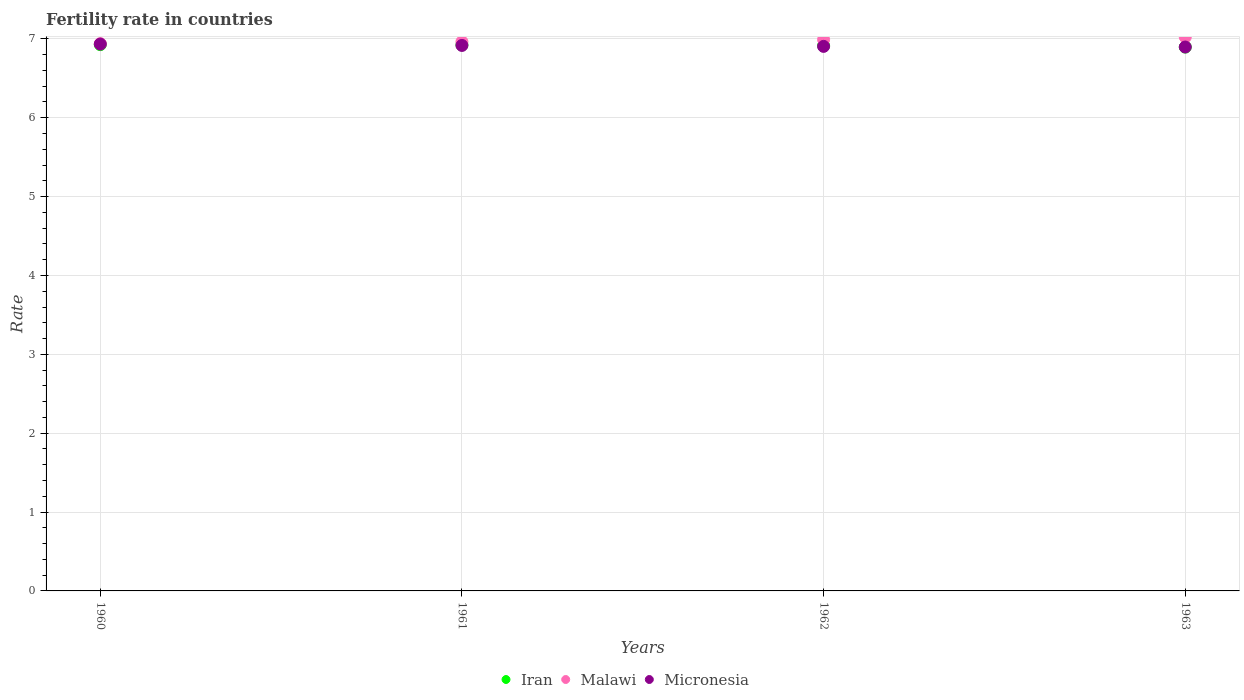How many different coloured dotlines are there?
Your response must be concise. 3. What is the fertility rate in Malawi in 1961?
Provide a short and direct response. 6.96. Across all years, what is the maximum fertility rate in Iran?
Provide a short and direct response. 6.93. Across all years, what is the minimum fertility rate in Iran?
Give a very brief answer. 6.9. What is the total fertility rate in Iran in the graph?
Provide a succinct answer. 27.66. What is the difference between the fertility rate in Iran in 1960 and that in 1962?
Offer a very short reply. 0.01. What is the difference between the fertility rate in Malawi in 1960 and the fertility rate in Iran in 1961?
Offer a terse response. 0.02. What is the average fertility rate in Malawi per year?
Your answer should be compact. 6.98. In the year 1961, what is the difference between the fertility rate in Micronesia and fertility rate in Malawi?
Your answer should be compact. -0.05. In how many years, is the fertility rate in Iran greater than 5.4?
Your answer should be very brief. 4. What is the ratio of the fertility rate in Iran in 1961 to that in 1963?
Your response must be concise. 1. Is the fertility rate in Malawi in 1960 less than that in 1962?
Provide a succinct answer. Yes. What is the difference between the highest and the second highest fertility rate in Malawi?
Offer a terse response. 0.03. What is the difference between the highest and the lowest fertility rate in Iran?
Offer a very short reply. 0.03. Is it the case that in every year, the sum of the fertility rate in Malawi and fertility rate in Iran  is greater than the fertility rate in Micronesia?
Provide a succinct answer. Yes. Does the fertility rate in Micronesia monotonically increase over the years?
Offer a very short reply. No. Is the fertility rate in Micronesia strictly greater than the fertility rate in Malawi over the years?
Keep it short and to the point. No. Is the fertility rate in Micronesia strictly less than the fertility rate in Malawi over the years?
Provide a short and direct response. Yes. How many dotlines are there?
Give a very brief answer. 3. What is the difference between two consecutive major ticks on the Y-axis?
Your response must be concise. 1. Are the values on the major ticks of Y-axis written in scientific E-notation?
Keep it short and to the point. No. Does the graph contain any zero values?
Your answer should be very brief. No. What is the title of the graph?
Give a very brief answer. Fertility rate in countries. Does "Faeroe Islands" appear as one of the legend labels in the graph?
Offer a very short reply. No. What is the label or title of the Y-axis?
Your answer should be compact. Rate. What is the Rate in Iran in 1960?
Give a very brief answer. 6.93. What is the Rate of Malawi in 1960?
Provide a short and direct response. 6.94. What is the Rate of Micronesia in 1960?
Make the answer very short. 6.93. What is the Rate of Iran in 1961?
Make the answer very short. 6.92. What is the Rate of Malawi in 1961?
Provide a succinct answer. 6.96. What is the Rate in Micronesia in 1961?
Provide a succinct answer. 6.92. What is the Rate of Iran in 1962?
Provide a succinct answer. 6.91. What is the Rate of Malawi in 1962?
Provide a succinct answer. 6.99. What is the Rate in Micronesia in 1962?
Your answer should be very brief. 6.91. What is the Rate of Iran in 1963?
Your answer should be very brief. 6.9. What is the Rate in Malawi in 1963?
Give a very brief answer. 7.02. What is the Rate of Micronesia in 1963?
Your answer should be compact. 6.9. Across all years, what is the maximum Rate in Iran?
Make the answer very short. 6.93. Across all years, what is the maximum Rate in Malawi?
Provide a succinct answer. 7.02. Across all years, what is the maximum Rate in Micronesia?
Provide a short and direct response. 6.93. Across all years, what is the minimum Rate in Iran?
Make the answer very short. 6.9. Across all years, what is the minimum Rate in Malawi?
Provide a succinct answer. 6.94. Across all years, what is the minimum Rate of Micronesia?
Ensure brevity in your answer.  6.9. What is the total Rate of Iran in the graph?
Your answer should be compact. 27.66. What is the total Rate of Malawi in the graph?
Your answer should be very brief. 27.92. What is the total Rate in Micronesia in the graph?
Ensure brevity in your answer.  27.65. What is the difference between the Rate in Iran in 1960 and that in 1961?
Offer a very short reply. 0. What is the difference between the Rate of Malawi in 1960 and that in 1961?
Keep it short and to the point. -0.02. What is the difference between the Rate of Micronesia in 1960 and that in 1961?
Your response must be concise. 0.02. What is the difference between the Rate in Iran in 1960 and that in 1962?
Ensure brevity in your answer.  0.01. What is the difference between the Rate of Malawi in 1960 and that in 1962?
Your answer should be compact. -0.05. What is the difference between the Rate of Micronesia in 1960 and that in 1962?
Give a very brief answer. 0.03. What is the difference between the Rate of Iran in 1960 and that in 1963?
Make the answer very short. 0.03. What is the difference between the Rate in Malawi in 1960 and that in 1963?
Offer a terse response. -0.08. What is the difference between the Rate of Micronesia in 1960 and that in 1963?
Ensure brevity in your answer.  0.04. What is the difference between the Rate of Malawi in 1961 and that in 1962?
Provide a short and direct response. -0.03. What is the difference between the Rate of Micronesia in 1961 and that in 1962?
Provide a succinct answer. 0.01. What is the difference between the Rate in Iran in 1961 and that in 1963?
Make the answer very short. 0.03. What is the difference between the Rate of Malawi in 1961 and that in 1963?
Provide a succinct answer. -0.06. What is the difference between the Rate in Iran in 1962 and that in 1963?
Ensure brevity in your answer.  0.02. What is the difference between the Rate in Malawi in 1962 and that in 1963?
Ensure brevity in your answer.  -0.03. What is the difference between the Rate of Micronesia in 1962 and that in 1963?
Your answer should be compact. 0.01. What is the difference between the Rate of Iran in 1960 and the Rate of Malawi in 1961?
Your response must be concise. -0.04. What is the difference between the Rate in Malawi in 1960 and the Rate in Micronesia in 1961?
Offer a very short reply. 0.02. What is the difference between the Rate of Iran in 1960 and the Rate of Malawi in 1962?
Offer a very short reply. -0.06. What is the difference between the Rate in Iran in 1960 and the Rate in Micronesia in 1962?
Make the answer very short. 0.02. What is the difference between the Rate of Malawi in 1960 and the Rate of Micronesia in 1962?
Your answer should be very brief. 0.04. What is the difference between the Rate of Iran in 1960 and the Rate of Malawi in 1963?
Offer a very short reply. -0.1. What is the difference between the Rate of Iran in 1960 and the Rate of Micronesia in 1963?
Provide a short and direct response. 0.03. What is the difference between the Rate of Malawi in 1960 and the Rate of Micronesia in 1963?
Provide a short and direct response. 0.04. What is the difference between the Rate of Iran in 1961 and the Rate of Malawi in 1962?
Keep it short and to the point. -0.07. What is the difference between the Rate in Iran in 1961 and the Rate in Micronesia in 1962?
Provide a short and direct response. 0.02. What is the difference between the Rate of Malawi in 1961 and the Rate of Micronesia in 1962?
Provide a succinct answer. 0.06. What is the difference between the Rate of Iran in 1961 and the Rate of Malawi in 1963?
Make the answer very short. -0.1. What is the difference between the Rate of Iran in 1961 and the Rate of Micronesia in 1963?
Your response must be concise. 0.03. What is the difference between the Rate in Malawi in 1961 and the Rate in Micronesia in 1963?
Provide a short and direct response. 0.07. What is the difference between the Rate of Iran in 1962 and the Rate of Malawi in 1963?
Your answer should be compact. -0.11. What is the difference between the Rate of Iran in 1962 and the Rate of Micronesia in 1963?
Give a very brief answer. 0.02. What is the difference between the Rate in Malawi in 1962 and the Rate in Micronesia in 1963?
Give a very brief answer. 0.09. What is the average Rate in Iran per year?
Your answer should be compact. 6.92. What is the average Rate in Malawi per year?
Your answer should be compact. 6.98. What is the average Rate of Micronesia per year?
Offer a terse response. 6.91. In the year 1960, what is the difference between the Rate of Iran and Rate of Malawi?
Offer a terse response. -0.01. In the year 1960, what is the difference between the Rate of Iran and Rate of Micronesia?
Your response must be concise. -0.01. In the year 1960, what is the difference between the Rate in Malawi and Rate in Micronesia?
Your response must be concise. 0.01. In the year 1961, what is the difference between the Rate in Iran and Rate in Malawi?
Keep it short and to the point. -0.04. In the year 1961, what is the difference between the Rate in Iran and Rate in Micronesia?
Make the answer very short. 0.01. In the year 1961, what is the difference between the Rate in Malawi and Rate in Micronesia?
Your answer should be very brief. 0.05. In the year 1962, what is the difference between the Rate of Iran and Rate of Malawi?
Offer a very short reply. -0.08. In the year 1962, what is the difference between the Rate of Iran and Rate of Micronesia?
Your answer should be very brief. 0.01. In the year 1962, what is the difference between the Rate of Malawi and Rate of Micronesia?
Give a very brief answer. 0.09. In the year 1963, what is the difference between the Rate of Iran and Rate of Malawi?
Ensure brevity in your answer.  -0.13. In the year 1963, what is the difference between the Rate of Iran and Rate of Micronesia?
Your response must be concise. -0. In the year 1963, what is the difference between the Rate of Malawi and Rate of Micronesia?
Make the answer very short. 0.13. What is the ratio of the Rate in Micronesia in 1960 to that in 1961?
Provide a short and direct response. 1. What is the ratio of the Rate of Iran in 1960 to that in 1962?
Keep it short and to the point. 1. What is the ratio of the Rate in Malawi in 1960 to that in 1962?
Keep it short and to the point. 0.99. What is the ratio of the Rate in Micronesia in 1960 to that in 1962?
Provide a succinct answer. 1. What is the ratio of the Rate in Iran in 1960 to that in 1963?
Offer a very short reply. 1. What is the ratio of the Rate in Micronesia in 1960 to that in 1963?
Keep it short and to the point. 1.01. What is the ratio of the Rate in Malawi in 1961 to that in 1962?
Your answer should be very brief. 1. What is the ratio of the Rate in Iran in 1962 to that in 1963?
Your answer should be compact. 1. What is the ratio of the Rate in Malawi in 1962 to that in 1963?
Your answer should be very brief. 1. What is the difference between the highest and the second highest Rate of Iran?
Give a very brief answer. 0. What is the difference between the highest and the second highest Rate of Malawi?
Your response must be concise. 0.03. What is the difference between the highest and the second highest Rate of Micronesia?
Keep it short and to the point. 0.02. What is the difference between the highest and the lowest Rate in Iran?
Provide a succinct answer. 0.03. What is the difference between the highest and the lowest Rate of Malawi?
Offer a terse response. 0.08. What is the difference between the highest and the lowest Rate in Micronesia?
Offer a terse response. 0.04. 